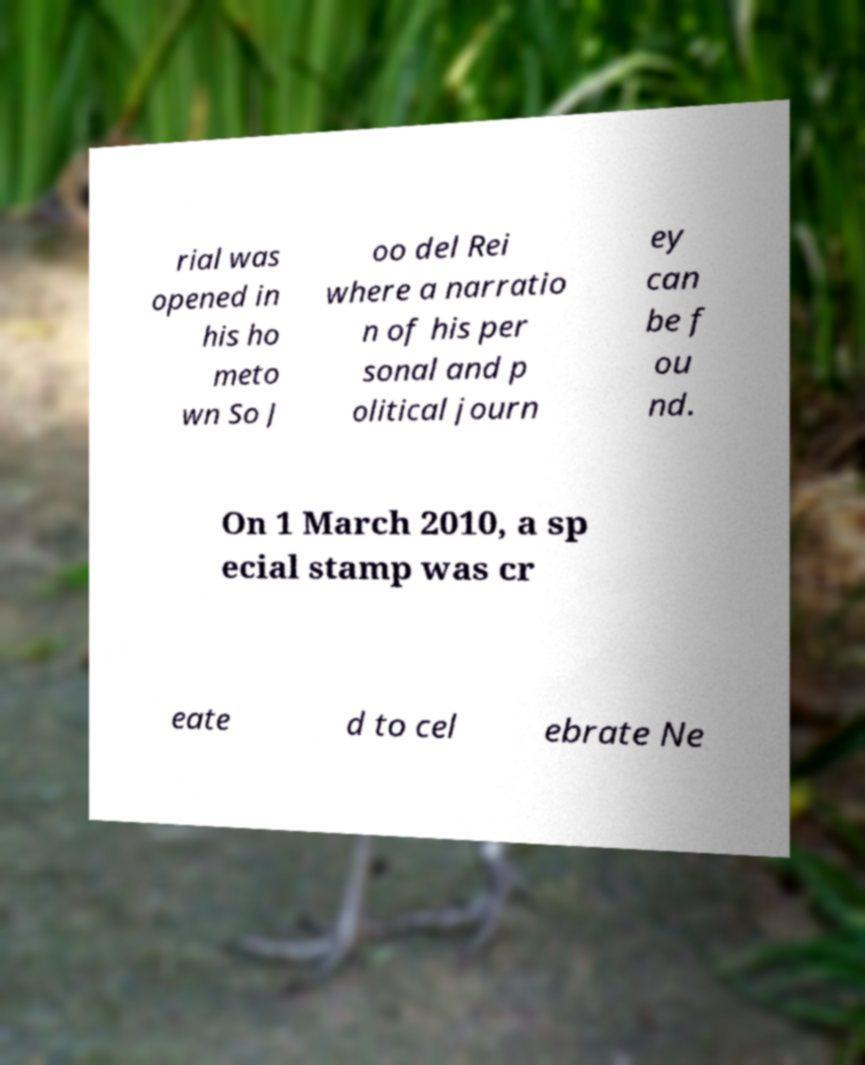What messages or text are displayed in this image? I need them in a readable, typed format. rial was opened in his ho meto wn So J oo del Rei where a narratio n of his per sonal and p olitical journ ey can be f ou nd. On 1 March 2010, a sp ecial stamp was cr eate d to cel ebrate Ne 